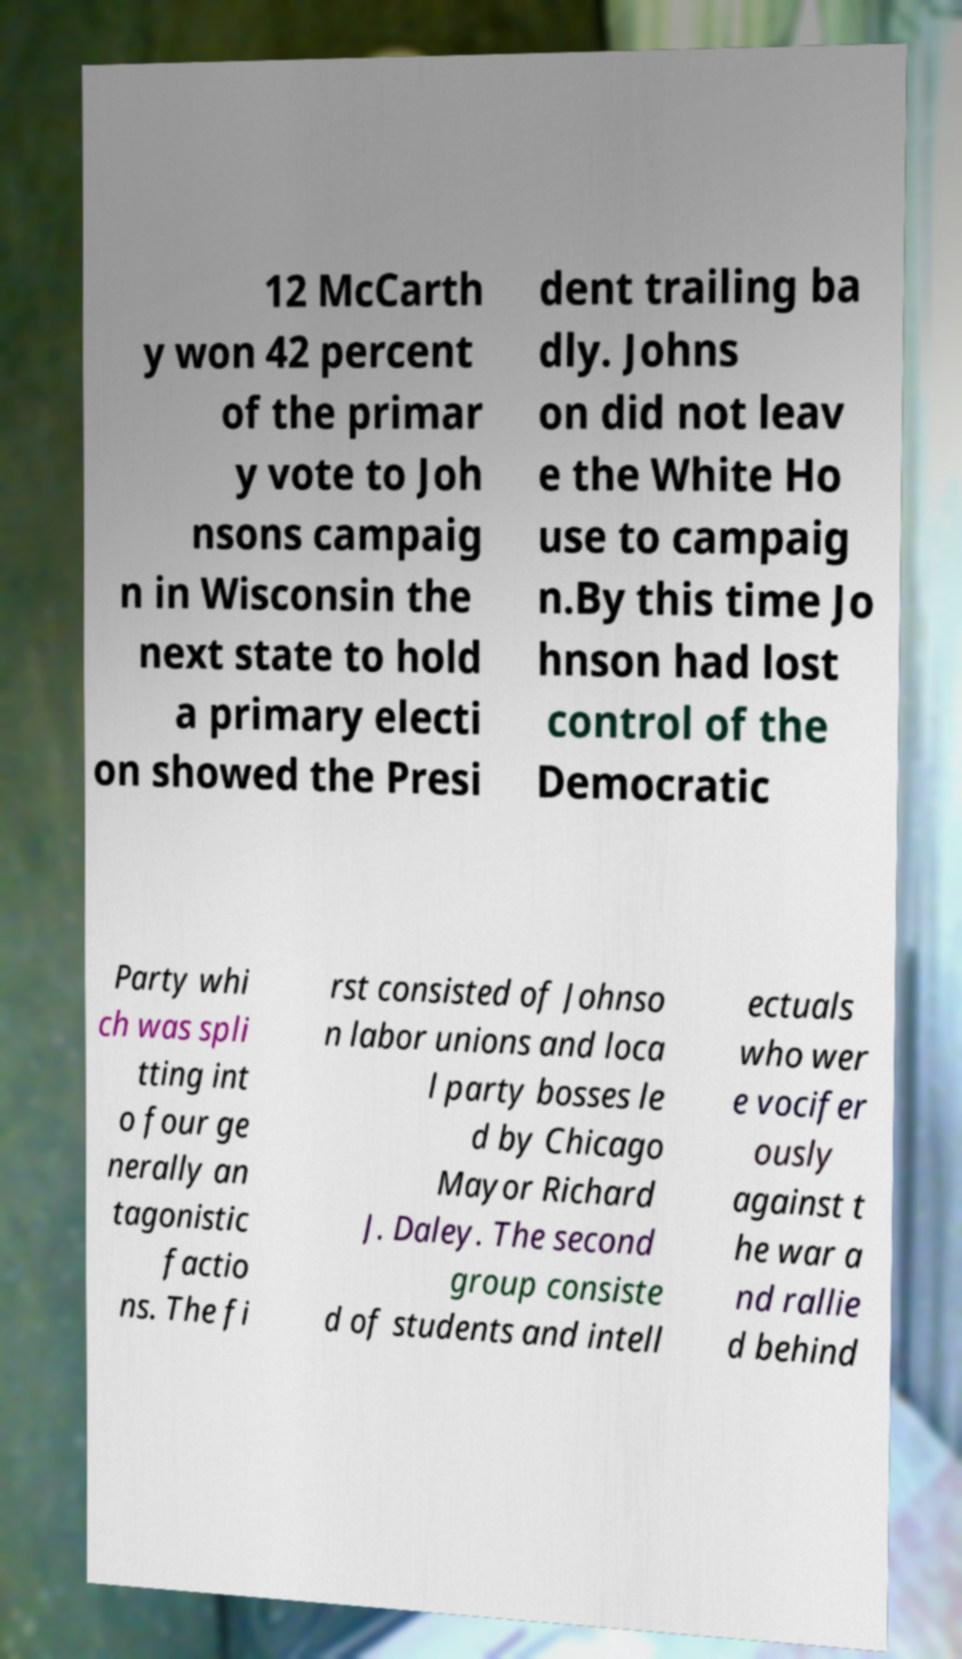Please read and relay the text visible in this image. What does it say? 12 McCarth y won 42 percent of the primar y vote to Joh nsons campaig n in Wisconsin the next state to hold a primary electi on showed the Presi dent trailing ba dly. Johns on did not leav e the White Ho use to campaig n.By this time Jo hnson had lost control of the Democratic Party whi ch was spli tting int o four ge nerally an tagonistic factio ns. The fi rst consisted of Johnso n labor unions and loca l party bosses le d by Chicago Mayor Richard J. Daley. The second group consiste d of students and intell ectuals who wer e vocifer ously against t he war a nd rallie d behind 